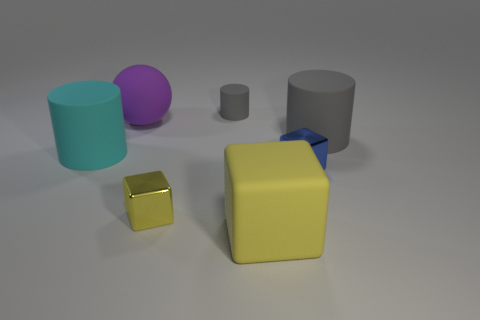What shape is the matte thing that is the same color as the small matte cylinder?
Keep it short and to the point. Cylinder. What number of other things are there of the same shape as the tiny blue metal object?
Provide a short and direct response. 2. The large gray rubber thing has what shape?
Offer a terse response. Cylinder. Does the small yellow object have the same material as the big gray cylinder?
Offer a terse response. No. Are there an equal number of yellow objects that are in front of the large cyan rubber cylinder and tiny gray matte cylinders to the left of the big sphere?
Make the answer very short. No. There is a small cube that is to the left of the cube right of the big yellow block; are there any big yellow matte objects that are behind it?
Your answer should be very brief. No. Is the yellow rubber block the same size as the rubber sphere?
Make the answer very short. Yes. What color is the metallic thing that is in front of the small block on the right side of the small thing behind the purple rubber sphere?
Make the answer very short. Yellow. What number of large things are the same color as the tiny rubber cylinder?
Keep it short and to the point. 1. How many tiny things are cyan matte objects or rubber cubes?
Your answer should be very brief. 0. 